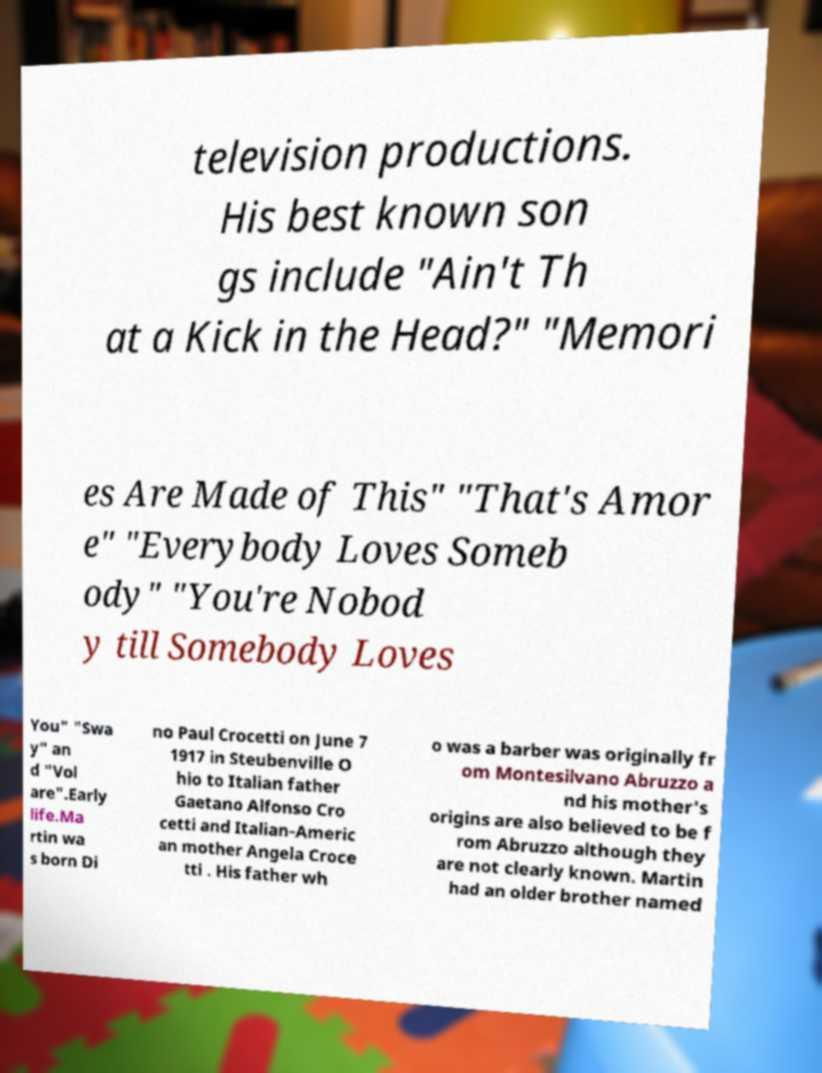I need the written content from this picture converted into text. Can you do that? television productions. His best known son gs include "Ain't Th at a Kick in the Head?" "Memori es Are Made of This" "That's Amor e" "Everybody Loves Someb ody" "You're Nobod y till Somebody Loves You" "Swa y" an d "Vol are".Early life.Ma rtin wa s born Di no Paul Crocetti on June 7 1917 in Steubenville O hio to Italian father Gaetano Alfonso Cro cetti and Italian-Americ an mother Angela Croce tti . His father wh o was a barber was originally fr om Montesilvano Abruzzo a nd his mother's origins are also believed to be f rom Abruzzo although they are not clearly known. Martin had an older brother named 